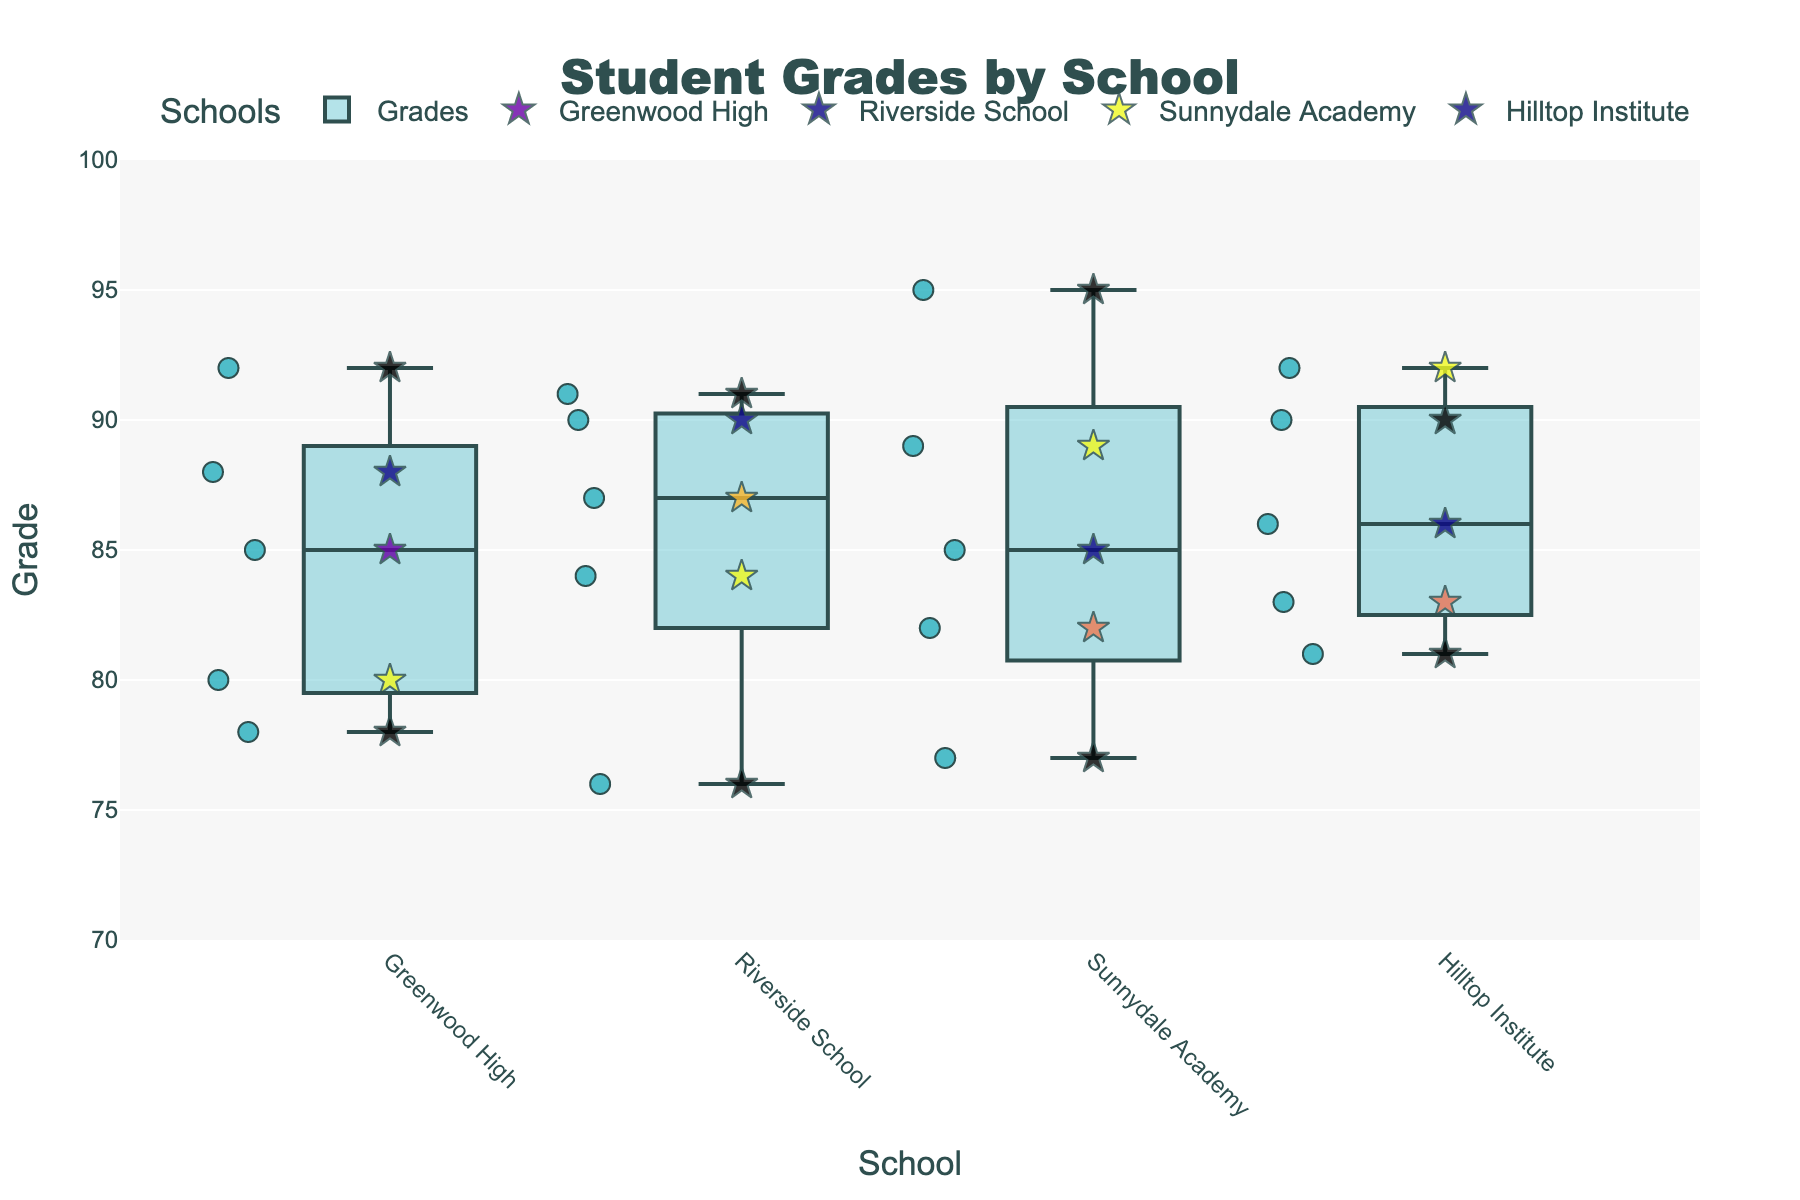how many schools are displayed in the plot? There are four distinct schools grouped in the plot. We can identify this by noting the unique school names along the x-axis.
Answer: 4 what is the title of the plot? The title of the plot is displayed at the top center of the figure.
Answer: Student Grades by School which school has the highest median grade? The median grade for each school can be identified by the central line inside each box. Hilltop Institute has the box plot with the highest central line.
Answer: Hilltop Institute which student achieved the highest grade, and what school do they belong to? By finding the highest scatter point on the y-axis, we see that Nick from Sunnydale Academy achieved the highest grade of 95.
Answer: Nick, Sunnydale Academy how many students from Greenwood High are above the school's median grade? Find the median line in the Greenwood High box plot, count the scatter points above this line. In this case, 2 students (Bob and Diana) are above the median grade of 85.
Answer: 2 compare the average grades of Riverside School and Sunnydale Academy. Calculate the average of individual grades for each school. For Riverside: (90 + 84 + 87 + 91 + 76)/5 = 85.6. For Sunnydale: (89 + 85 + 82 + 95 + 77)/5 = 85.6. Thus, both schools have the same average grade.
Answer: 85.6 for both which school has the greatest range in student grades? The range is the difference between the highest and lowest grades in each box plot. By comparing ranges: Greenwood High (92 - 78 = 14), Riverside School (91 - 76 = 15), Sunnydale Academy (95 - 77 = 18), Hilltop Institute (92 - 81 = 11). Sunnydale Academy has the greatest range.
Answer: Sunnydale Academy are there any outliers in the dataset, and if so, which schools have them? Since all scatter points are within the whiskers and there are no points outside the boxes, there are no outliers in this dataset.
Answer: no outliers what is the interquartile range (IQR) for Hilltop Institute? IQR = Q3 - Q1, where Q1 is the lower quartile (25th percentile) and Q3 is the upper quartile (75th percentile). For Hilltop Institute, look visually to estimate: Q1 ~ 83 and Q3 ~ 90. Therefore, IQR = 90 - 83 = 7.
Answer: 7 